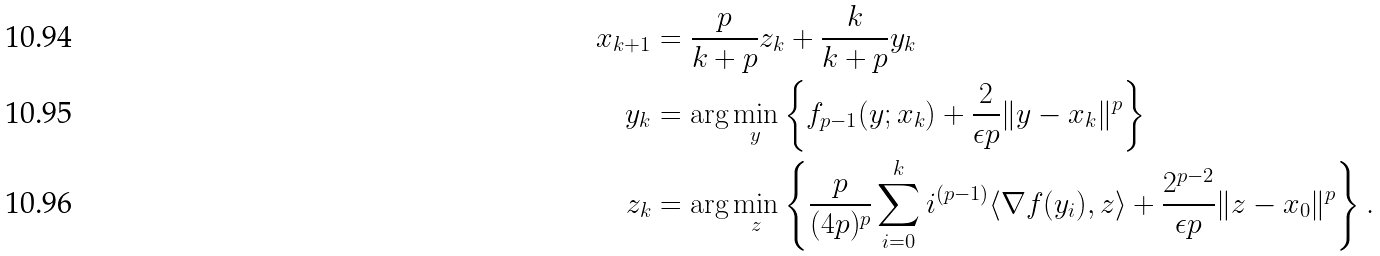<formula> <loc_0><loc_0><loc_500><loc_500>x _ { k + 1 } & = \frac { p } { k + p } z _ { k } + \frac { k } { k + p } y _ { k } \\ y _ { k } & = \arg \min _ { y } \left \{ f _ { p - 1 } ( y ; x _ { k } ) + \frac { 2 } { \epsilon p } \| y - x _ { k } \| ^ { p } \right \} \\ z _ { k } & = \arg \min _ { z } \left \{ \frac { p } { ( 4 p ) ^ { p } } \sum _ { i = 0 } ^ { k } i ^ { ( p - 1 ) } \langle \nabla f ( y _ { i } ) , z \rangle + \frac { 2 ^ { p - 2 } } { \epsilon p } \| z - x _ { 0 } \| ^ { p } \right \} .</formula> 